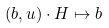<formula> <loc_0><loc_0><loc_500><loc_500>( b , u ) \cdot H \mapsto b</formula> 